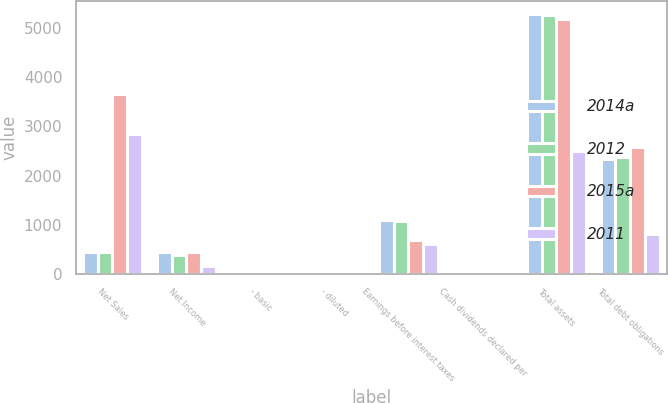Convert chart. <chart><loc_0><loc_0><loc_500><loc_500><stacked_bar_chart><ecel><fcel>Net Sales<fcel>Net Income<fcel>- basic<fcel>- diluted<fcel>Earnings before interest taxes<fcel>Cash dividends declared per<fcel>Total assets<fcel>Total debt obligations<nl><fcel>2014a<fcel>439.05<fcel>436.8<fcel>4.47<fcel>4.47<fcel>1106.5<fcel>2.2<fcel>5284.6<fcel>2332<nl><fcel>2012<fcel>439.05<fcel>392.6<fcel>3.99<fcel>3.99<fcel>1083.7<fcel>1.6<fcel>5272.8<fcel>2379.3<nl><fcel>2015a<fcel>3665.3<fcel>441.3<fcel>4.57<fcel>4.52<fcel>683.7<fcel>1.51<fcel>5196.2<fcel>2572.7<nl><fcel>2011<fcel>2843.9<fcel>160.2<fcel>1.66<fcel>1.64<fcel>608.3<fcel>1<fcel>2494.9<fcel>819.5<nl></chart> 